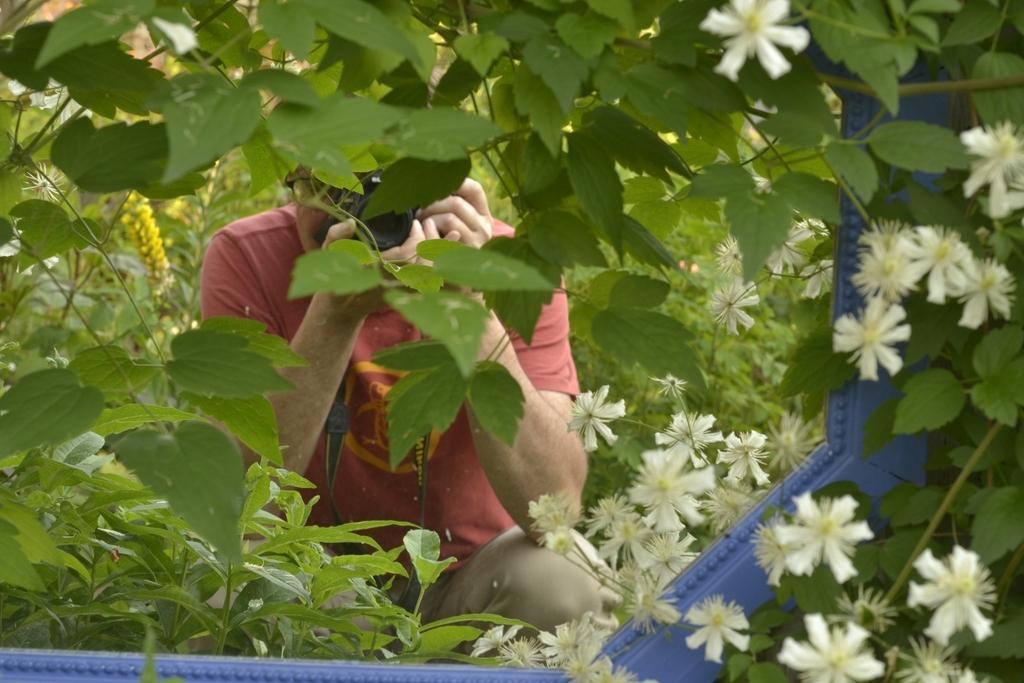Can you describe this image briefly? In this picture I can see there is a man sitting and clicking the pictures and he is wearing a t-shirt and there are few plants around him and there are flowers to the plants. They are in white color. 